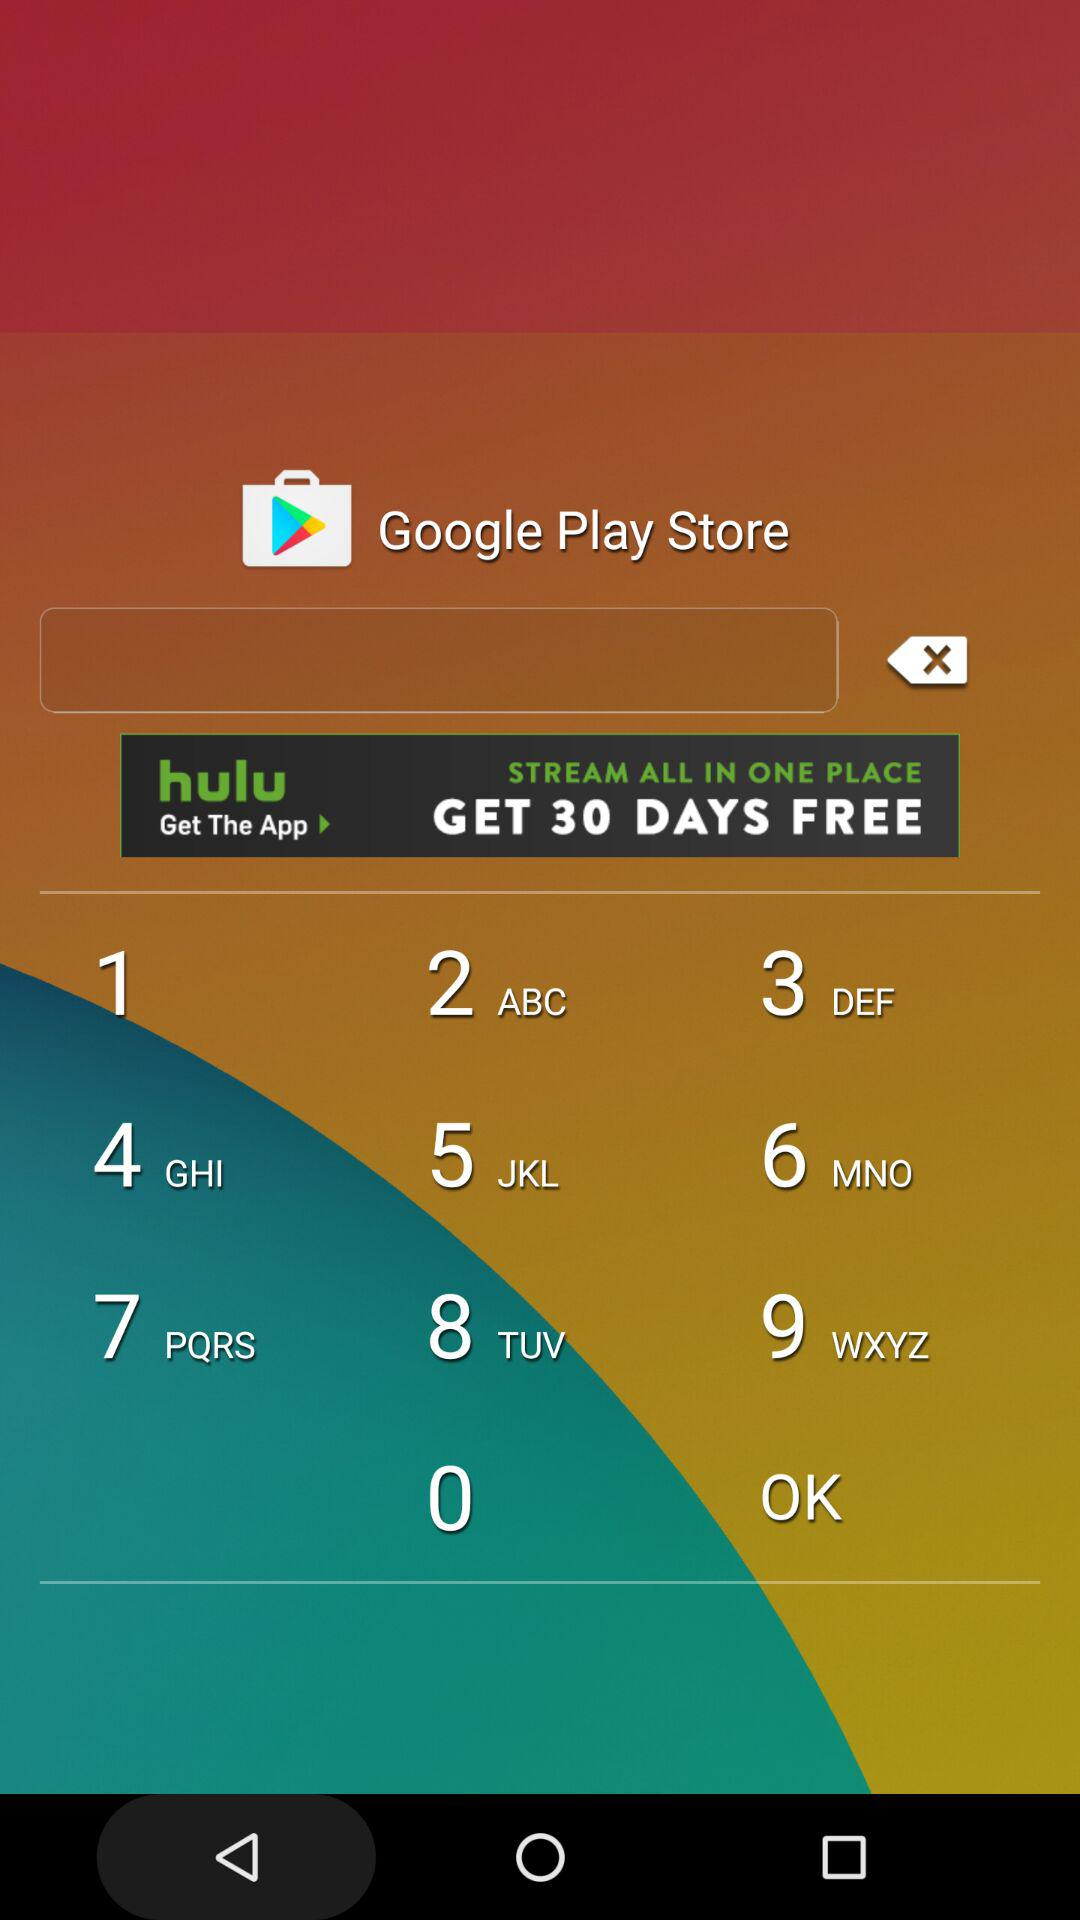What is the maximum claim amount for a maiden claiming at 12:22 PM? The maximum claim amount is $30,000. 